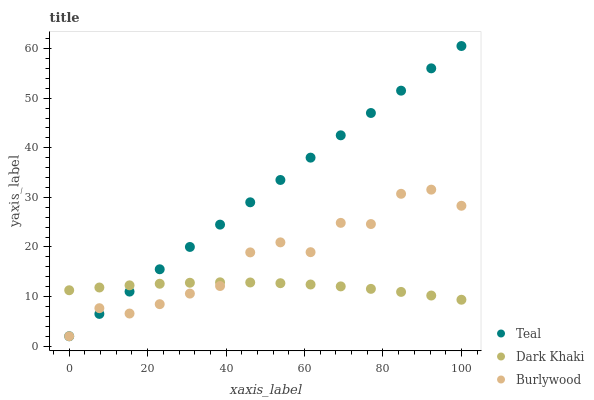Does Dark Khaki have the minimum area under the curve?
Answer yes or no. Yes. Does Teal have the maximum area under the curve?
Answer yes or no. Yes. Does Burlywood have the minimum area under the curve?
Answer yes or no. No. Does Burlywood have the maximum area under the curve?
Answer yes or no. No. Is Teal the smoothest?
Answer yes or no. Yes. Is Burlywood the roughest?
Answer yes or no. Yes. Is Burlywood the smoothest?
Answer yes or no. No. Is Teal the roughest?
Answer yes or no. No. Does Burlywood have the lowest value?
Answer yes or no. Yes. Does Teal have the highest value?
Answer yes or no. Yes. Does Burlywood have the highest value?
Answer yes or no. No. Does Burlywood intersect Teal?
Answer yes or no. Yes. Is Burlywood less than Teal?
Answer yes or no. No. Is Burlywood greater than Teal?
Answer yes or no. No. 